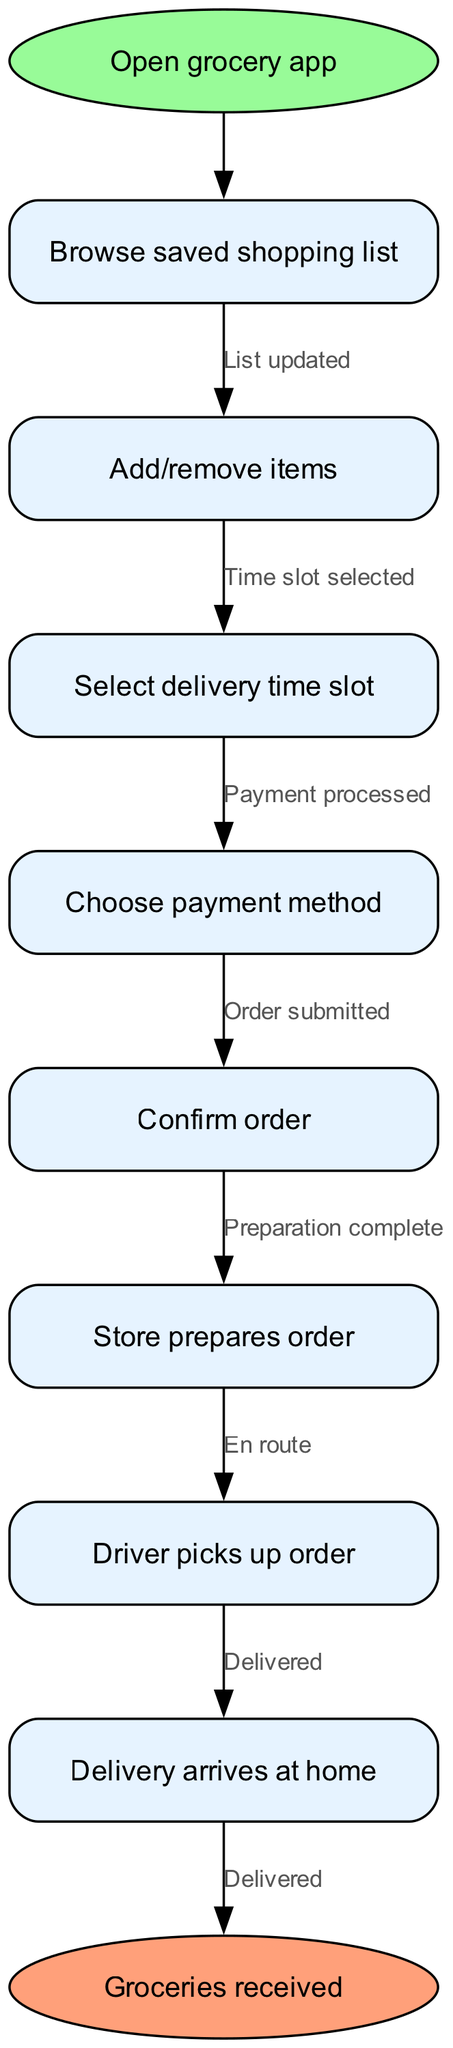What is the first action in the process? The process starts with the action of opening the grocery app, indicated as the first node in the diagram.
Answer: Open grocery app How many nodes are there in total? The total number of process nodes, including the start and end nodes, is counted. There are 8 nodes in the diagram.
Answer: 8 What connects "Choose payment method" and "Confirm order"? The relationship between these two nodes is established through the edge, which signifies that the payment method must be chosen before the order can be confirmed.
Answer: Payment processed What is the last action before groceries are received? The last action before receiving groceries is the delivery arriving at home, which is the final process node before reaching the end of the diagram.
Answer: Delivery arrives at home What happens after "Store prepares order"? The next step after the store prepares the order is that the driver picks up the order, as indicated in the connection from that node.
Answer: Driver picks up order How many edges are depicted in the flowchart? Counting the connections between the nodes shows that there are 7 edges in total, representing the transitions between actions.
Answer: 7 What is the delivery time selected after? The selected delivery time slot occurs after confirming the items on the shopping list and making any necessary adjustments to it, indicating a sequential flow.
Answer: Select delivery time slot Which node has an ellipse shape? The nodes with an ellipse shape are reserved for the start and end points of the process, both marked distinctly in the diagram.
Answer: Start and end 